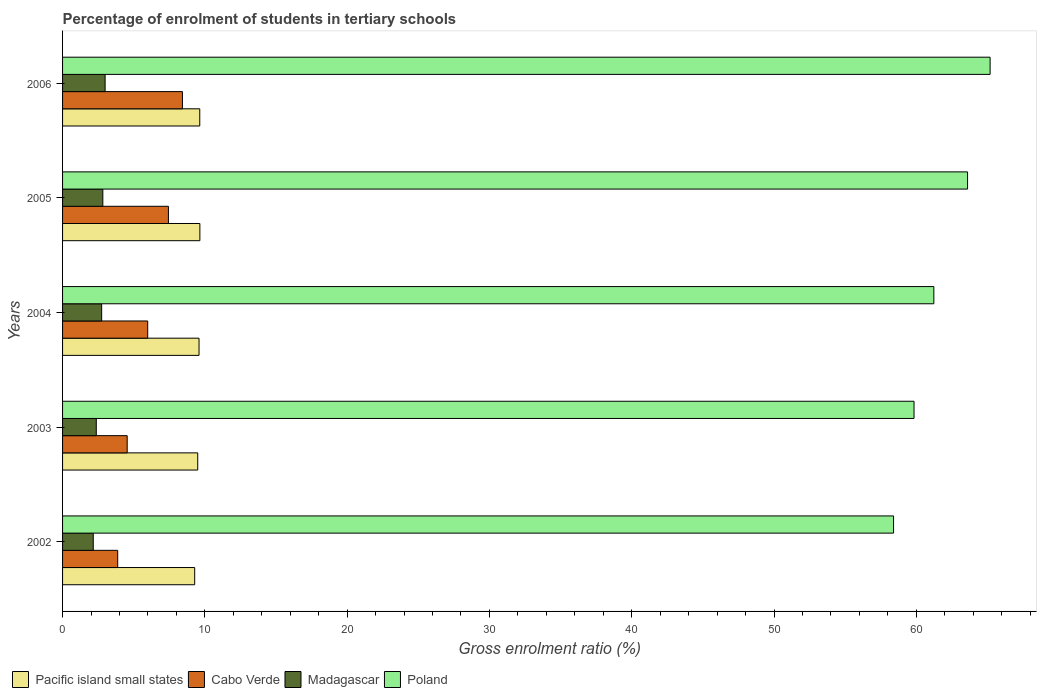How many different coloured bars are there?
Keep it short and to the point. 4. How many bars are there on the 3rd tick from the top?
Provide a short and direct response. 4. In how many cases, is the number of bars for a given year not equal to the number of legend labels?
Provide a short and direct response. 0. What is the percentage of students enrolled in tertiary schools in Poland in 2006?
Give a very brief answer. 65.19. Across all years, what is the maximum percentage of students enrolled in tertiary schools in Madagascar?
Ensure brevity in your answer.  2.99. Across all years, what is the minimum percentage of students enrolled in tertiary schools in Poland?
Your answer should be very brief. 58.4. In which year was the percentage of students enrolled in tertiary schools in Poland minimum?
Keep it short and to the point. 2002. What is the total percentage of students enrolled in tertiary schools in Cabo Verde in the graph?
Ensure brevity in your answer.  30.26. What is the difference between the percentage of students enrolled in tertiary schools in Cabo Verde in 2003 and that in 2005?
Make the answer very short. -2.9. What is the difference between the percentage of students enrolled in tertiary schools in Poland in 2004 and the percentage of students enrolled in tertiary schools in Pacific island small states in 2006?
Ensure brevity in your answer.  51.59. What is the average percentage of students enrolled in tertiary schools in Poland per year?
Offer a terse response. 61.65. In the year 2006, what is the difference between the percentage of students enrolled in tertiary schools in Madagascar and percentage of students enrolled in tertiary schools in Cabo Verde?
Give a very brief answer. -5.44. What is the ratio of the percentage of students enrolled in tertiary schools in Poland in 2002 to that in 2005?
Provide a succinct answer. 0.92. Is the percentage of students enrolled in tertiary schools in Poland in 2005 less than that in 2006?
Provide a succinct answer. Yes. Is the difference between the percentage of students enrolled in tertiary schools in Madagascar in 2003 and 2005 greater than the difference between the percentage of students enrolled in tertiary schools in Cabo Verde in 2003 and 2005?
Provide a short and direct response. Yes. What is the difference between the highest and the second highest percentage of students enrolled in tertiary schools in Cabo Verde?
Offer a terse response. 0.98. What is the difference between the highest and the lowest percentage of students enrolled in tertiary schools in Pacific island small states?
Your answer should be compact. 0.36. In how many years, is the percentage of students enrolled in tertiary schools in Cabo Verde greater than the average percentage of students enrolled in tertiary schools in Cabo Verde taken over all years?
Ensure brevity in your answer.  2. Is the sum of the percentage of students enrolled in tertiary schools in Madagascar in 2002 and 2005 greater than the maximum percentage of students enrolled in tertiary schools in Poland across all years?
Provide a short and direct response. No. Is it the case that in every year, the sum of the percentage of students enrolled in tertiary schools in Poland and percentage of students enrolled in tertiary schools in Pacific island small states is greater than the sum of percentage of students enrolled in tertiary schools in Madagascar and percentage of students enrolled in tertiary schools in Cabo Verde?
Your response must be concise. Yes. What does the 2nd bar from the top in 2002 represents?
Give a very brief answer. Madagascar. What does the 1st bar from the bottom in 2006 represents?
Ensure brevity in your answer.  Pacific island small states. How many bars are there?
Your response must be concise. 20. How many years are there in the graph?
Offer a very short reply. 5. Does the graph contain any zero values?
Keep it short and to the point. No. Does the graph contain grids?
Provide a short and direct response. No. Where does the legend appear in the graph?
Offer a terse response. Bottom left. How many legend labels are there?
Make the answer very short. 4. How are the legend labels stacked?
Keep it short and to the point. Horizontal. What is the title of the graph?
Offer a terse response. Percentage of enrolment of students in tertiary schools. Does "Turks and Caicos Islands" appear as one of the legend labels in the graph?
Provide a succinct answer. No. What is the label or title of the X-axis?
Provide a short and direct response. Gross enrolment ratio (%). What is the label or title of the Y-axis?
Keep it short and to the point. Years. What is the Gross enrolment ratio (%) of Pacific island small states in 2002?
Ensure brevity in your answer.  9.28. What is the Gross enrolment ratio (%) of Cabo Verde in 2002?
Make the answer very short. 3.87. What is the Gross enrolment ratio (%) of Madagascar in 2002?
Keep it short and to the point. 2.16. What is the Gross enrolment ratio (%) of Poland in 2002?
Your response must be concise. 58.4. What is the Gross enrolment ratio (%) in Pacific island small states in 2003?
Your answer should be compact. 9.5. What is the Gross enrolment ratio (%) of Cabo Verde in 2003?
Your answer should be compact. 4.54. What is the Gross enrolment ratio (%) in Madagascar in 2003?
Provide a succinct answer. 2.37. What is the Gross enrolment ratio (%) of Poland in 2003?
Your answer should be compact. 59.84. What is the Gross enrolment ratio (%) of Pacific island small states in 2004?
Your answer should be compact. 9.59. What is the Gross enrolment ratio (%) of Cabo Verde in 2004?
Ensure brevity in your answer.  5.98. What is the Gross enrolment ratio (%) in Madagascar in 2004?
Your answer should be very brief. 2.75. What is the Gross enrolment ratio (%) of Poland in 2004?
Provide a short and direct response. 61.23. What is the Gross enrolment ratio (%) of Pacific island small states in 2005?
Offer a very short reply. 9.65. What is the Gross enrolment ratio (%) of Cabo Verde in 2005?
Provide a succinct answer. 7.44. What is the Gross enrolment ratio (%) of Madagascar in 2005?
Ensure brevity in your answer.  2.83. What is the Gross enrolment ratio (%) of Poland in 2005?
Your response must be concise. 63.6. What is the Gross enrolment ratio (%) in Pacific island small states in 2006?
Your answer should be very brief. 9.64. What is the Gross enrolment ratio (%) of Cabo Verde in 2006?
Provide a short and direct response. 8.42. What is the Gross enrolment ratio (%) in Madagascar in 2006?
Your response must be concise. 2.99. What is the Gross enrolment ratio (%) in Poland in 2006?
Ensure brevity in your answer.  65.19. Across all years, what is the maximum Gross enrolment ratio (%) in Pacific island small states?
Provide a short and direct response. 9.65. Across all years, what is the maximum Gross enrolment ratio (%) of Cabo Verde?
Make the answer very short. 8.42. Across all years, what is the maximum Gross enrolment ratio (%) of Madagascar?
Keep it short and to the point. 2.99. Across all years, what is the maximum Gross enrolment ratio (%) in Poland?
Give a very brief answer. 65.19. Across all years, what is the minimum Gross enrolment ratio (%) of Pacific island small states?
Offer a terse response. 9.28. Across all years, what is the minimum Gross enrolment ratio (%) in Cabo Verde?
Give a very brief answer. 3.87. Across all years, what is the minimum Gross enrolment ratio (%) of Madagascar?
Offer a terse response. 2.16. Across all years, what is the minimum Gross enrolment ratio (%) in Poland?
Ensure brevity in your answer.  58.4. What is the total Gross enrolment ratio (%) in Pacific island small states in the graph?
Keep it short and to the point. 47.67. What is the total Gross enrolment ratio (%) in Cabo Verde in the graph?
Your answer should be very brief. 30.26. What is the total Gross enrolment ratio (%) in Madagascar in the graph?
Offer a terse response. 13.09. What is the total Gross enrolment ratio (%) of Poland in the graph?
Offer a very short reply. 308.26. What is the difference between the Gross enrolment ratio (%) in Pacific island small states in 2002 and that in 2003?
Your answer should be compact. -0.21. What is the difference between the Gross enrolment ratio (%) of Cabo Verde in 2002 and that in 2003?
Your answer should be compact. -0.67. What is the difference between the Gross enrolment ratio (%) of Madagascar in 2002 and that in 2003?
Your response must be concise. -0.21. What is the difference between the Gross enrolment ratio (%) of Poland in 2002 and that in 2003?
Offer a terse response. -1.44. What is the difference between the Gross enrolment ratio (%) in Pacific island small states in 2002 and that in 2004?
Your answer should be very brief. -0.31. What is the difference between the Gross enrolment ratio (%) of Cabo Verde in 2002 and that in 2004?
Provide a succinct answer. -2.11. What is the difference between the Gross enrolment ratio (%) in Madagascar in 2002 and that in 2004?
Ensure brevity in your answer.  -0.59. What is the difference between the Gross enrolment ratio (%) in Poland in 2002 and that in 2004?
Make the answer very short. -2.83. What is the difference between the Gross enrolment ratio (%) of Pacific island small states in 2002 and that in 2005?
Provide a succinct answer. -0.36. What is the difference between the Gross enrolment ratio (%) in Cabo Verde in 2002 and that in 2005?
Give a very brief answer. -3.56. What is the difference between the Gross enrolment ratio (%) of Madagascar in 2002 and that in 2005?
Ensure brevity in your answer.  -0.67. What is the difference between the Gross enrolment ratio (%) in Poland in 2002 and that in 2005?
Offer a terse response. -5.2. What is the difference between the Gross enrolment ratio (%) in Pacific island small states in 2002 and that in 2006?
Ensure brevity in your answer.  -0.36. What is the difference between the Gross enrolment ratio (%) in Cabo Verde in 2002 and that in 2006?
Your answer should be compact. -4.55. What is the difference between the Gross enrolment ratio (%) of Madagascar in 2002 and that in 2006?
Make the answer very short. -0.83. What is the difference between the Gross enrolment ratio (%) in Poland in 2002 and that in 2006?
Give a very brief answer. -6.79. What is the difference between the Gross enrolment ratio (%) of Pacific island small states in 2003 and that in 2004?
Offer a terse response. -0.09. What is the difference between the Gross enrolment ratio (%) in Cabo Verde in 2003 and that in 2004?
Your response must be concise. -1.44. What is the difference between the Gross enrolment ratio (%) of Madagascar in 2003 and that in 2004?
Provide a succinct answer. -0.38. What is the difference between the Gross enrolment ratio (%) in Poland in 2003 and that in 2004?
Offer a very short reply. -1.39. What is the difference between the Gross enrolment ratio (%) in Pacific island small states in 2003 and that in 2005?
Provide a short and direct response. -0.15. What is the difference between the Gross enrolment ratio (%) in Cabo Verde in 2003 and that in 2005?
Provide a succinct answer. -2.9. What is the difference between the Gross enrolment ratio (%) of Madagascar in 2003 and that in 2005?
Your answer should be very brief. -0.46. What is the difference between the Gross enrolment ratio (%) in Poland in 2003 and that in 2005?
Offer a terse response. -3.76. What is the difference between the Gross enrolment ratio (%) of Pacific island small states in 2003 and that in 2006?
Give a very brief answer. -0.14. What is the difference between the Gross enrolment ratio (%) in Cabo Verde in 2003 and that in 2006?
Make the answer very short. -3.88. What is the difference between the Gross enrolment ratio (%) of Madagascar in 2003 and that in 2006?
Offer a very short reply. -0.62. What is the difference between the Gross enrolment ratio (%) in Poland in 2003 and that in 2006?
Your answer should be compact. -5.35. What is the difference between the Gross enrolment ratio (%) of Pacific island small states in 2004 and that in 2005?
Make the answer very short. -0.06. What is the difference between the Gross enrolment ratio (%) of Cabo Verde in 2004 and that in 2005?
Make the answer very short. -1.46. What is the difference between the Gross enrolment ratio (%) of Madagascar in 2004 and that in 2005?
Give a very brief answer. -0.08. What is the difference between the Gross enrolment ratio (%) in Poland in 2004 and that in 2005?
Your answer should be very brief. -2.37. What is the difference between the Gross enrolment ratio (%) of Pacific island small states in 2004 and that in 2006?
Ensure brevity in your answer.  -0.05. What is the difference between the Gross enrolment ratio (%) of Cabo Verde in 2004 and that in 2006?
Keep it short and to the point. -2.44. What is the difference between the Gross enrolment ratio (%) of Madagascar in 2004 and that in 2006?
Provide a succinct answer. -0.24. What is the difference between the Gross enrolment ratio (%) of Poland in 2004 and that in 2006?
Provide a succinct answer. -3.95. What is the difference between the Gross enrolment ratio (%) in Pacific island small states in 2005 and that in 2006?
Provide a succinct answer. 0.01. What is the difference between the Gross enrolment ratio (%) of Cabo Verde in 2005 and that in 2006?
Make the answer very short. -0.98. What is the difference between the Gross enrolment ratio (%) in Madagascar in 2005 and that in 2006?
Ensure brevity in your answer.  -0.16. What is the difference between the Gross enrolment ratio (%) in Poland in 2005 and that in 2006?
Make the answer very short. -1.59. What is the difference between the Gross enrolment ratio (%) in Pacific island small states in 2002 and the Gross enrolment ratio (%) in Cabo Verde in 2003?
Provide a succinct answer. 4.74. What is the difference between the Gross enrolment ratio (%) of Pacific island small states in 2002 and the Gross enrolment ratio (%) of Madagascar in 2003?
Offer a very short reply. 6.92. What is the difference between the Gross enrolment ratio (%) in Pacific island small states in 2002 and the Gross enrolment ratio (%) in Poland in 2003?
Your answer should be compact. -50.55. What is the difference between the Gross enrolment ratio (%) in Cabo Verde in 2002 and the Gross enrolment ratio (%) in Madagascar in 2003?
Keep it short and to the point. 1.51. What is the difference between the Gross enrolment ratio (%) of Cabo Verde in 2002 and the Gross enrolment ratio (%) of Poland in 2003?
Offer a terse response. -55.96. What is the difference between the Gross enrolment ratio (%) in Madagascar in 2002 and the Gross enrolment ratio (%) in Poland in 2003?
Offer a very short reply. -57.68. What is the difference between the Gross enrolment ratio (%) of Pacific island small states in 2002 and the Gross enrolment ratio (%) of Cabo Verde in 2004?
Your answer should be very brief. 3.3. What is the difference between the Gross enrolment ratio (%) in Pacific island small states in 2002 and the Gross enrolment ratio (%) in Madagascar in 2004?
Your answer should be compact. 6.54. What is the difference between the Gross enrolment ratio (%) in Pacific island small states in 2002 and the Gross enrolment ratio (%) in Poland in 2004?
Your response must be concise. -51.95. What is the difference between the Gross enrolment ratio (%) of Cabo Verde in 2002 and the Gross enrolment ratio (%) of Madagascar in 2004?
Keep it short and to the point. 1.13. What is the difference between the Gross enrolment ratio (%) in Cabo Verde in 2002 and the Gross enrolment ratio (%) in Poland in 2004?
Make the answer very short. -57.36. What is the difference between the Gross enrolment ratio (%) of Madagascar in 2002 and the Gross enrolment ratio (%) of Poland in 2004?
Your answer should be very brief. -59.07. What is the difference between the Gross enrolment ratio (%) in Pacific island small states in 2002 and the Gross enrolment ratio (%) in Cabo Verde in 2005?
Your answer should be very brief. 1.84. What is the difference between the Gross enrolment ratio (%) of Pacific island small states in 2002 and the Gross enrolment ratio (%) of Madagascar in 2005?
Offer a very short reply. 6.46. What is the difference between the Gross enrolment ratio (%) in Pacific island small states in 2002 and the Gross enrolment ratio (%) in Poland in 2005?
Offer a terse response. -54.32. What is the difference between the Gross enrolment ratio (%) in Cabo Verde in 2002 and the Gross enrolment ratio (%) in Madagascar in 2005?
Make the answer very short. 1.05. What is the difference between the Gross enrolment ratio (%) in Cabo Verde in 2002 and the Gross enrolment ratio (%) in Poland in 2005?
Your response must be concise. -59.73. What is the difference between the Gross enrolment ratio (%) in Madagascar in 2002 and the Gross enrolment ratio (%) in Poland in 2005?
Offer a terse response. -61.44. What is the difference between the Gross enrolment ratio (%) of Pacific island small states in 2002 and the Gross enrolment ratio (%) of Cabo Verde in 2006?
Make the answer very short. 0.86. What is the difference between the Gross enrolment ratio (%) of Pacific island small states in 2002 and the Gross enrolment ratio (%) of Madagascar in 2006?
Offer a very short reply. 6.3. What is the difference between the Gross enrolment ratio (%) in Pacific island small states in 2002 and the Gross enrolment ratio (%) in Poland in 2006?
Keep it short and to the point. -55.9. What is the difference between the Gross enrolment ratio (%) of Cabo Verde in 2002 and the Gross enrolment ratio (%) of Madagascar in 2006?
Your response must be concise. 0.89. What is the difference between the Gross enrolment ratio (%) of Cabo Verde in 2002 and the Gross enrolment ratio (%) of Poland in 2006?
Your answer should be very brief. -61.31. What is the difference between the Gross enrolment ratio (%) in Madagascar in 2002 and the Gross enrolment ratio (%) in Poland in 2006?
Keep it short and to the point. -63.03. What is the difference between the Gross enrolment ratio (%) of Pacific island small states in 2003 and the Gross enrolment ratio (%) of Cabo Verde in 2004?
Provide a succinct answer. 3.52. What is the difference between the Gross enrolment ratio (%) in Pacific island small states in 2003 and the Gross enrolment ratio (%) in Madagascar in 2004?
Your response must be concise. 6.75. What is the difference between the Gross enrolment ratio (%) of Pacific island small states in 2003 and the Gross enrolment ratio (%) of Poland in 2004?
Your answer should be compact. -51.73. What is the difference between the Gross enrolment ratio (%) of Cabo Verde in 2003 and the Gross enrolment ratio (%) of Madagascar in 2004?
Your answer should be very brief. 1.79. What is the difference between the Gross enrolment ratio (%) of Cabo Verde in 2003 and the Gross enrolment ratio (%) of Poland in 2004?
Keep it short and to the point. -56.69. What is the difference between the Gross enrolment ratio (%) of Madagascar in 2003 and the Gross enrolment ratio (%) of Poland in 2004?
Provide a short and direct response. -58.86. What is the difference between the Gross enrolment ratio (%) of Pacific island small states in 2003 and the Gross enrolment ratio (%) of Cabo Verde in 2005?
Offer a very short reply. 2.06. What is the difference between the Gross enrolment ratio (%) of Pacific island small states in 2003 and the Gross enrolment ratio (%) of Madagascar in 2005?
Your response must be concise. 6.67. What is the difference between the Gross enrolment ratio (%) in Pacific island small states in 2003 and the Gross enrolment ratio (%) in Poland in 2005?
Your answer should be compact. -54.1. What is the difference between the Gross enrolment ratio (%) of Cabo Verde in 2003 and the Gross enrolment ratio (%) of Madagascar in 2005?
Offer a very short reply. 1.71. What is the difference between the Gross enrolment ratio (%) in Cabo Verde in 2003 and the Gross enrolment ratio (%) in Poland in 2005?
Your answer should be compact. -59.06. What is the difference between the Gross enrolment ratio (%) in Madagascar in 2003 and the Gross enrolment ratio (%) in Poland in 2005?
Provide a succinct answer. -61.23. What is the difference between the Gross enrolment ratio (%) in Pacific island small states in 2003 and the Gross enrolment ratio (%) in Cabo Verde in 2006?
Your answer should be very brief. 1.07. What is the difference between the Gross enrolment ratio (%) in Pacific island small states in 2003 and the Gross enrolment ratio (%) in Madagascar in 2006?
Make the answer very short. 6.51. What is the difference between the Gross enrolment ratio (%) in Pacific island small states in 2003 and the Gross enrolment ratio (%) in Poland in 2006?
Give a very brief answer. -55.69. What is the difference between the Gross enrolment ratio (%) of Cabo Verde in 2003 and the Gross enrolment ratio (%) of Madagascar in 2006?
Offer a terse response. 1.55. What is the difference between the Gross enrolment ratio (%) of Cabo Verde in 2003 and the Gross enrolment ratio (%) of Poland in 2006?
Provide a succinct answer. -60.64. What is the difference between the Gross enrolment ratio (%) in Madagascar in 2003 and the Gross enrolment ratio (%) in Poland in 2006?
Your response must be concise. -62.82. What is the difference between the Gross enrolment ratio (%) in Pacific island small states in 2004 and the Gross enrolment ratio (%) in Cabo Verde in 2005?
Offer a very short reply. 2.15. What is the difference between the Gross enrolment ratio (%) in Pacific island small states in 2004 and the Gross enrolment ratio (%) in Madagascar in 2005?
Give a very brief answer. 6.76. What is the difference between the Gross enrolment ratio (%) of Pacific island small states in 2004 and the Gross enrolment ratio (%) of Poland in 2005?
Your answer should be compact. -54.01. What is the difference between the Gross enrolment ratio (%) of Cabo Verde in 2004 and the Gross enrolment ratio (%) of Madagascar in 2005?
Your answer should be very brief. 3.15. What is the difference between the Gross enrolment ratio (%) of Cabo Verde in 2004 and the Gross enrolment ratio (%) of Poland in 2005?
Your answer should be very brief. -57.62. What is the difference between the Gross enrolment ratio (%) of Madagascar in 2004 and the Gross enrolment ratio (%) of Poland in 2005?
Provide a short and direct response. -60.85. What is the difference between the Gross enrolment ratio (%) in Pacific island small states in 2004 and the Gross enrolment ratio (%) in Cabo Verde in 2006?
Make the answer very short. 1.17. What is the difference between the Gross enrolment ratio (%) in Pacific island small states in 2004 and the Gross enrolment ratio (%) in Madagascar in 2006?
Provide a succinct answer. 6.6. What is the difference between the Gross enrolment ratio (%) in Pacific island small states in 2004 and the Gross enrolment ratio (%) in Poland in 2006?
Ensure brevity in your answer.  -55.6. What is the difference between the Gross enrolment ratio (%) in Cabo Verde in 2004 and the Gross enrolment ratio (%) in Madagascar in 2006?
Your response must be concise. 2.99. What is the difference between the Gross enrolment ratio (%) of Cabo Verde in 2004 and the Gross enrolment ratio (%) of Poland in 2006?
Offer a very short reply. -59.2. What is the difference between the Gross enrolment ratio (%) of Madagascar in 2004 and the Gross enrolment ratio (%) of Poland in 2006?
Offer a terse response. -62.44. What is the difference between the Gross enrolment ratio (%) of Pacific island small states in 2005 and the Gross enrolment ratio (%) of Cabo Verde in 2006?
Provide a short and direct response. 1.22. What is the difference between the Gross enrolment ratio (%) in Pacific island small states in 2005 and the Gross enrolment ratio (%) in Madagascar in 2006?
Your response must be concise. 6.66. What is the difference between the Gross enrolment ratio (%) in Pacific island small states in 2005 and the Gross enrolment ratio (%) in Poland in 2006?
Provide a short and direct response. -55.54. What is the difference between the Gross enrolment ratio (%) in Cabo Verde in 2005 and the Gross enrolment ratio (%) in Madagascar in 2006?
Offer a very short reply. 4.45. What is the difference between the Gross enrolment ratio (%) in Cabo Verde in 2005 and the Gross enrolment ratio (%) in Poland in 2006?
Provide a succinct answer. -57.75. What is the difference between the Gross enrolment ratio (%) in Madagascar in 2005 and the Gross enrolment ratio (%) in Poland in 2006?
Give a very brief answer. -62.36. What is the average Gross enrolment ratio (%) in Pacific island small states per year?
Ensure brevity in your answer.  9.53. What is the average Gross enrolment ratio (%) in Cabo Verde per year?
Offer a very short reply. 6.05. What is the average Gross enrolment ratio (%) in Madagascar per year?
Keep it short and to the point. 2.62. What is the average Gross enrolment ratio (%) of Poland per year?
Your answer should be very brief. 61.65. In the year 2002, what is the difference between the Gross enrolment ratio (%) in Pacific island small states and Gross enrolment ratio (%) in Cabo Verde?
Keep it short and to the point. 5.41. In the year 2002, what is the difference between the Gross enrolment ratio (%) in Pacific island small states and Gross enrolment ratio (%) in Madagascar?
Ensure brevity in your answer.  7.13. In the year 2002, what is the difference between the Gross enrolment ratio (%) of Pacific island small states and Gross enrolment ratio (%) of Poland?
Make the answer very short. -49.12. In the year 2002, what is the difference between the Gross enrolment ratio (%) of Cabo Verde and Gross enrolment ratio (%) of Madagascar?
Your answer should be very brief. 1.72. In the year 2002, what is the difference between the Gross enrolment ratio (%) of Cabo Verde and Gross enrolment ratio (%) of Poland?
Provide a short and direct response. -54.53. In the year 2002, what is the difference between the Gross enrolment ratio (%) of Madagascar and Gross enrolment ratio (%) of Poland?
Make the answer very short. -56.24. In the year 2003, what is the difference between the Gross enrolment ratio (%) of Pacific island small states and Gross enrolment ratio (%) of Cabo Verde?
Your response must be concise. 4.96. In the year 2003, what is the difference between the Gross enrolment ratio (%) in Pacific island small states and Gross enrolment ratio (%) in Madagascar?
Provide a short and direct response. 7.13. In the year 2003, what is the difference between the Gross enrolment ratio (%) of Pacific island small states and Gross enrolment ratio (%) of Poland?
Keep it short and to the point. -50.34. In the year 2003, what is the difference between the Gross enrolment ratio (%) of Cabo Verde and Gross enrolment ratio (%) of Madagascar?
Provide a short and direct response. 2.17. In the year 2003, what is the difference between the Gross enrolment ratio (%) in Cabo Verde and Gross enrolment ratio (%) in Poland?
Offer a very short reply. -55.3. In the year 2003, what is the difference between the Gross enrolment ratio (%) of Madagascar and Gross enrolment ratio (%) of Poland?
Offer a terse response. -57.47. In the year 2004, what is the difference between the Gross enrolment ratio (%) in Pacific island small states and Gross enrolment ratio (%) in Cabo Verde?
Keep it short and to the point. 3.61. In the year 2004, what is the difference between the Gross enrolment ratio (%) in Pacific island small states and Gross enrolment ratio (%) in Madagascar?
Offer a very short reply. 6.84. In the year 2004, what is the difference between the Gross enrolment ratio (%) in Pacific island small states and Gross enrolment ratio (%) in Poland?
Provide a succinct answer. -51.64. In the year 2004, what is the difference between the Gross enrolment ratio (%) of Cabo Verde and Gross enrolment ratio (%) of Madagascar?
Offer a very short reply. 3.24. In the year 2004, what is the difference between the Gross enrolment ratio (%) in Cabo Verde and Gross enrolment ratio (%) in Poland?
Give a very brief answer. -55.25. In the year 2004, what is the difference between the Gross enrolment ratio (%) in Madagascar and Gross enrolment ratio (%) in Poland?
Make the answer very short. -58.48. In the year 2005, what is the difference between the Gross enrolment ratio (%) in Pacific island small states and Gross enrolment ratio (%) in Cabo Verde?
Make the answer very short. 2.21. In the year 2005, what is the difference between the Gross enrolment ratio (%) of Pacific island small states and Gross enrolment ratio (%) of Madagascar?
Provide a short and direct response. 6.82. In the year 2005, what is the difference between the Gross enrolment ratio (%) of Pacific island small states and Gross enrolment ratio (%) of Poland?
Give a very brief answer. -53.95. In the year 2005, what is the difference between the Gross enrolment ratio (%) of Cabo Verde and Gross enrolment ratio (%) of Madagascar?
Your response must be concise. 4.61. In the year 2005, what is the difference between the Gross enrolment ratio (%) of Cabo Verde and Gross enrolment ratio (%) of Poland?
Offer a very short reply. -56.16. In the year 2005, what is the difference between the Gross enrolment ratio (%) in Madagascar and Gross enrolment ratio (%) in Poland?
Give a very brief answer. -60.77. In the year 2006, what is the difference between the Gross enrolment ratio (%) of Pacific island small states and Gross enrolment ratio (%) of Cabo Verde?
Keep it short and to the point. 1.22. In the year 2006, what is the difference between the Gross enrolment ratio (%) of Pacific island small states and Gross enrolment ratio (%) of Madagascar?
Offer a terse response. 6.65. In the year 2006, what is the difference between the Gross enrolment ratio (%) in Pacific island small states and Gross enrolment ratio (%) in Poland?
Provide a short and direct response. -55.54. In the year 2006, what is the difference between the Gross enrolment ratio (%) in Cabo Verde and Gross enrolment ratio (%) in Madagascar?
Make the answer very short. 5.44. In the year 2006, what is the difference between the Gross enrolment ratio (%) of Cabo Verde and Gross enrolment ratio (%) of Poland?
Make the answer very short. -56.76. In the year 2006, what is the difference between the Gross enrolment ratio (%) in Madagascar and Gross enrolment ratio (%) in Poland?
Ensure brevity in your answer.  -62.2. What is the ratio of the Gross enrolment ratio (%) of Pacific island small states in 2002 to that in 2003?
Ensure brevity in your answer.  0.98. What is the ratio of the Gross enrolment ratio (%) in Cabo Verde in 2002 to that in 2003?
Your answer should be very brief. 0.85. What is the ratio of the Gross enrolment ratio (%) in Madagascar in 2002 to that in 2003?
Offer a very short reply. 0.91. What is the ratio of the Gross enrolment ratio (%) of Poland in 2002 to that in 2003?
Your answer should be compact. 0.98. What is the ratio of the Gross enrolment ratio (%) in Pacific island small states in 2002 to that in 2004?
Provide a short and direct response. 0.97. What is the ratio of the Gross enrolment ratio (%) of Cabo Verde in 2002 to that in 2004?
Offer a very short reply. 0.65. What is the ratio of the Gross enrolment ratio (%) in Madagascar in 2002 to that in 2004?
Your answer should be very brief. 0.78. What is the ratio of the Gross enrolment ratio (%) in Poland in 2002 to that in 2004?
Your answer should be compact. 0.95. What is the ratio of the Gross enrolment ratio (%) in Pacific island small states in 2002 to that in 2005?
Keep it short and to the point. 0.96. What is the ratio of the Gross enrolment ratio (%) in Cabo Verde in 2002 to that in 2005?
Offer a very short reply. 0.52. What is the ratio of the Gross enrolment ratio (%) in Madagascar in 2002 to that in 2005?
Your answer should be compact. 0.76. What is the ratio of the Gross enrolment ratio (%) in Poland in 2002 to that in 2005?
Your response must be concise. 0.92. What is the ratio of the Gross enrolment ratio (%) of Pacific island small states in 2002 to that in 2006?
Make the answer very short. 0.96. What is the ratio of the Gross enrolment ratio (%) of Cabo Verde in 2002 to that in 2006?
Provide a short and direct response. 0.46. What is the ratio of the Gross enrolment ratio (%) in Madagascar in 2002 to that in 2006?
Your response must be concise. 0.72. What is the ratio of the Gross enrolment ratio (%) in Poland in 2002 to that in 2006?
Provide a succinct answer. 0.9. What is the ratio of the Gross enrolment ratio (%) in Cabo Verde in 2003 to that in 2004?
Provide a succinct answer. 0.76. What is the ratio of the Gross enrolment ratio (%) in Madagascar in 2003 to that in 2004?
Make the answer very short. 0.86. What is the ratio of the Gross enrolment ratio (%) of Poland in 2003 to that in 2004?
Your response must be concise. 0.98. What is the ratio of the Gross enrolment ratio (%) in Pacific island small states in 2003 to that in 2005?
Give a very brief answer. 0.98. What is the ratio of the Gross enrolment ratio (%) of Cabo Verde in 2003 to that in 2005?
Your answer should be very brief. 0.61. What is the ratio of the Gross enrolment ratio (%) in Madagascar in 2003 to that in 2005?
Make the answer very short. 0.84. What is the ratio of the Gross enrolment ratio (%) of Poland in 2003 to that in 2005?
Your answer should be very brief. 0.94. What is the ratio of the Gross enrolment ratio (%) in Pacific island small states in 2003 to that in 2006?
Your response must be concise. 0.99. What is the ratio of the Gross enrolment ratio (%) in Cabo Verde in 2003 to that in 2006?
Keep it short and to the point. 0.54. What is the ratio of the Gross enrolment ratio (%) in Madagascar in 2003 to that in 2006?
Your answer should be very brief. 0.79. What is the ratio of the Gross enrolment ratio (%) in Poland in 2003 to that in 2006?
Provide a short and direct response. 0.92. What is the ratio of the Gross enrolment ratio (%) of Pacific island small states in 2004 to that in 2005?
Your response must be concise. 0.99. What is the ratio of the Gross enrolment ratio (%) of Cabo Verde in 2004 to that in 2005?
Make the answer very short. 0.8. What is the ratio of the Gross enrolment ratio (%) in Madagascar in 2004 to that in 2005?
Provide a short and direct response. 0.97. What is the ratio of the Gross enrolment ratio (%) in Poland in 2004 to that in 2005?
Give a very brief answer. 0.96. What is the ratio of the Gross enrolment ratio (%) in Pacific island small states in 2004 to that in 2006?
Ensure brevity in your answer.  0.99. What is the ratio of the Gross enrolment ratio (%) of Cabo Verde in 2004 to that in 2006?
Ensure brevity in your answer.  0.71. What is the ratio of the Gross enrolment ratio (%) in Madagascar in 2004 to that in 2006?
Provide a short and direct response. 0.92. What is the ratio of the Gross enrolment ratio (%) of Poland in 2004 to that in 2006?
Your response must be concise. 0.94. What is the ratio of the Gross enrolment ratio (%) in Cabo Verde in 2005 to that in 2006?
Make the answer very short. 0.88. What is the ratio of the Gross enrolment ratio (%) in Madagascar in 2005 to that in 2006?
Your answer should be compact. 0.95. What is the ratio of the Gross enrolment ratio (%) in Poland in 2005 to that in 2006?
Make the answer very short. 0.98. What is the difference between the highest and the second highest Gross enrolment ratio (%) in Pacific island small states?
Your response must be concise. 0.01. What is the difference between the highest and the second highest Gross enrolment ratio (%) of Madagascar?
Give a very brief answer. 0.16. What is the difference between the highest and the second highest Gross enrolment ratio (%) of Poland?
Your answer should be compact. 1.59. What is the difference between the highest and the lowest Gross enrolment ratio (%) in Pacific island small states?
Your answer should be very brief. 0.36. What is the difference between the highest and the lowest Gross enrolment ratio (%) in Cabo Verde?
Keep it short and to the point. 4.55. What is the difference between the highest and the lowest Gross enrolment ratio (%) of Madagascar?
Make the answer very short. 0.83. What is the difference between the highest and the lowest Gross enrolment ratio (%) of Poland?
Your answer should be compact. 6.79. 